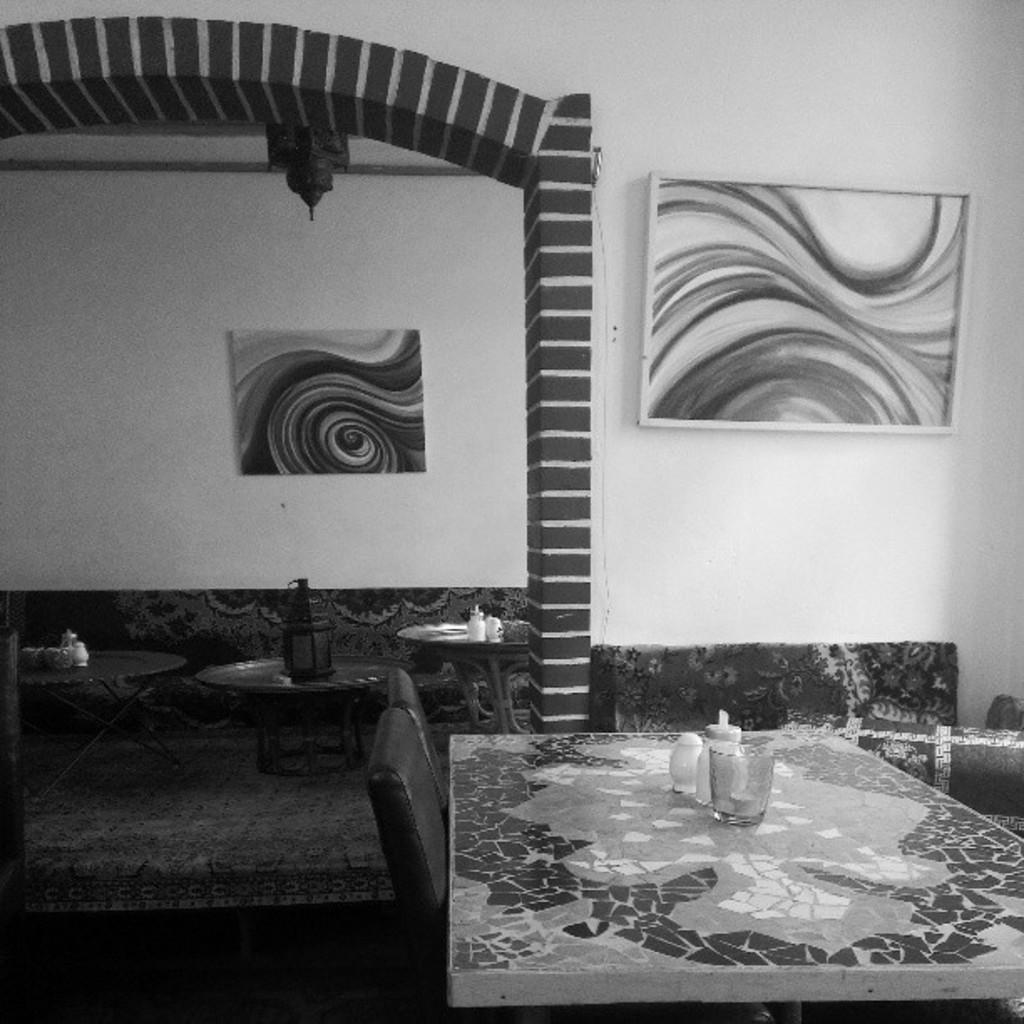Please provide a concise description of this image. In the image we can see a frame, wall, chairs, table, on the table there is a glass and other objects, and this is a floor. 